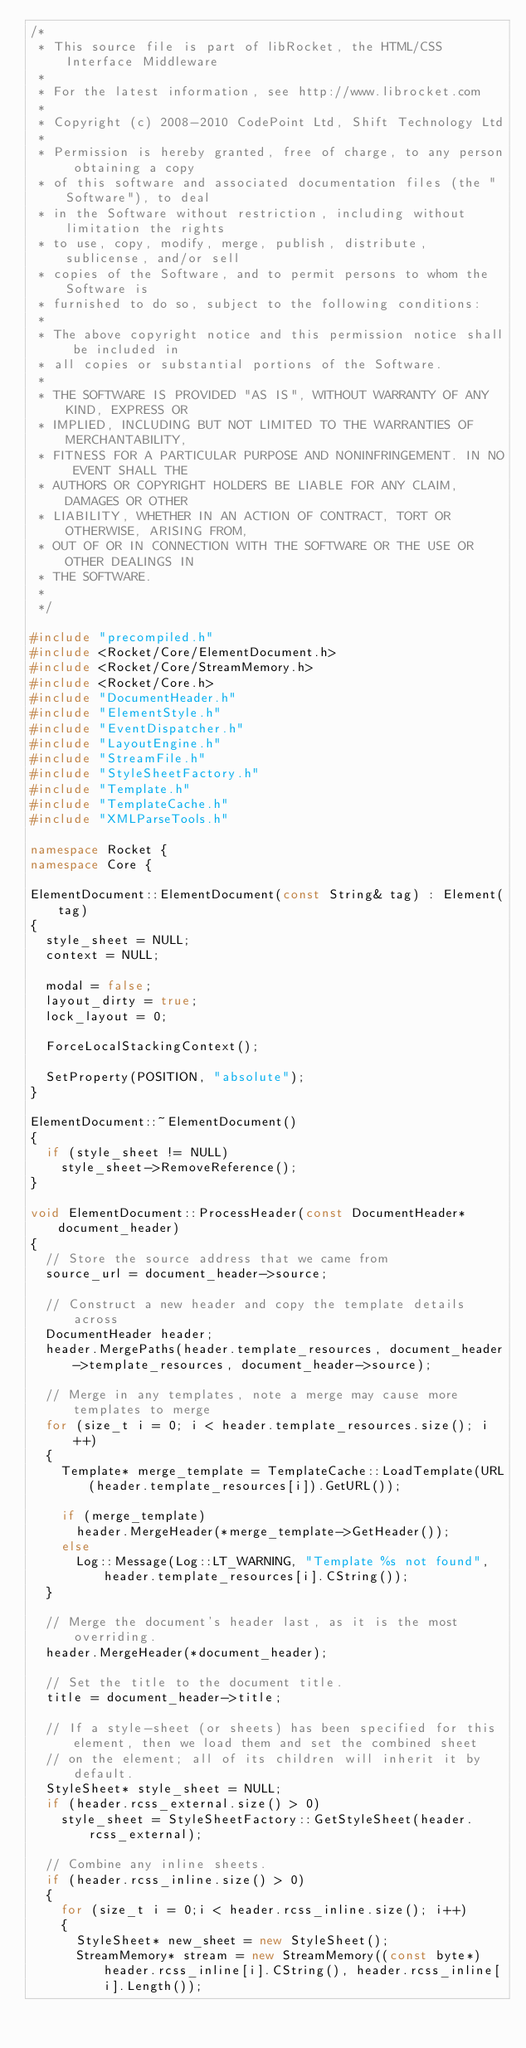Convert code to text. <code><loc_0><loc_0><loc_500><loc_500><_C++_>/*
 * This source file is part of libRocket, the HTML/CSS Interface Middleware
 *
 * For the latest information, see http://www.librocket.com
 *
 * Copyright (c) 2008-2010 CodePoint Ltd, Shift Technology Ltd
 *
 * Permission is hereby granted, free of charge, to any person obtaining a copy
 * of this software and associated documentation files (the "Software"), to deal
 * in the Software without restriction, including without limitation the rights
 * to use, copy, modify, merge, publish, distribute, sublicense, and/or sell
 * copies of the Software, and to permit persons to whom the Software is
 * furnished to do so, subject to the following conditions:
 *
 * The above copyright notice and this permission notice shall be included in
 * all copies or substantial portions of the Software.
 * 
 * THE SOFTWARE IS PROVIDED "AS IS", WITHOUT WARRANTY OF ANY KIND, EXPRESS OR
 * IMPLIED, INCLUDING BUT NOT LIMITED TO THE WARRANTIES OF MERCHANTABILITY,
 * FITNESS FOR A PARTICULAR PURPOSE AND NONINFRINGEMENT. IN NO EVENT SHALL THE
 * AUTHORS OR COPYRIGHT HOLDERS BE LIABLE FOR ANY CLAIM, DAMAGES OR OTHER
 * LIABILITY, WHETHER IN AN ACTION OF CONTRACT, TORT OR OTHERWISE, ARISING FROM,
 * OUT OF OR IN CONNECTION WITH THE SOFTWARE OR THE USE OR OTHER DEALINGS IN
 * THE SOFTWARE.
 *
 */

#include "precompiled.h"
#include <Rocket/Core/ElementDocument.h>
#include <Rocket/Core/StreamMemory.h>
#include <Rocket/Core.h>
#include "DocumentHeader.h"
#include "ElementStyle.h"
#include "EventDispatcher.h"
#include "LayoutEngine.h"
#include "StreamFile.h"
#include "StyleSheetFactory.h"
#include "Template.h"
#include "TemplateCache.h"
#include "XMLParseTools.h"

namespace Rocket {
namespace Core {

ElementDocument::ElementDocument(const String& tag) : Element(tag)
{
	style_sheet = NULL;
	context = NULL;

	modal = false;
	layout_dirty = true;
	lock_layout = 0;

	ForceLocalStackingContext();

	SetProperty(POSITION, "absolute");
}

ElementDocument::~ElementDocument()
{
	if (style_sheet != NULL)
		style_sheet->RemoveReference();
}

void ElementDocument::ProcessHeader(const DocumentHeader* document_header)
{	
	// Store the source address that we came from
	source_url = document_header->source;

	// Construct a new header and copy the template details across
	DocumentHeader header;
	header.MergePaths(header.template_resources, document_header->template_resources, document_header->source);

	// Merge in any templates, note a merge may cause more templates to merge
	for (size_t i = 0; i < header.template_resources.size(); i++)
	{
		Template* merge_template = TemplateCache::LoadTemplate(URL(header.template_resources[i]).GetURL());	

		if (merge_template)
			header.MergeHeader(*merge_template->GetHeader());
		else
			Log::Message(Log::LT_WARNING, "Template %s not found", header.template_resources[i].CString());
	}

	// Merge the document's header last, as it is the most overriding.
	header.MergeHeader(*document_header);

	// Set the title to the document title.
	title = document_header->title;

	// If a style-sheet (or sheets) has been specified for this element, then we load them and set the combined sheet
	// on the element; all of its children will inherit it by default.
	StyleSheet* style_sheet = NULL;
	if (header.rcss_external.size() > 0)
		style_sheet = StyleSheetFactory::GetStyleSheet(header.rcss_external);

	// Combine any inline sheets.
	if (header.rcss_inline.size() > 0)
	{			
		for (size_t i = 0;i < header.rcss_inline.size(); i++)
		{			
			StyleSheet* new_sheet = new StyleSheet();
			StreamMemory* stream = new StreamMemory((const byte*) header.rcss_inline[i].CString(), header.rcss_inline[i].Length());</code> 